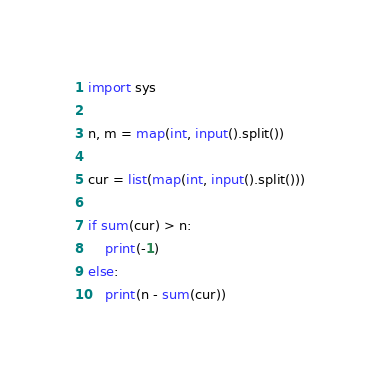<code> <loc_0><loc_0><loc_500><loc_500><_Python_>import sys

n, m = map(int, input().split())

cur = list(map(int, input().split()))

if sum(cur) > n:
    print(-1)
else:
    print(n - sum(cur))</code> 